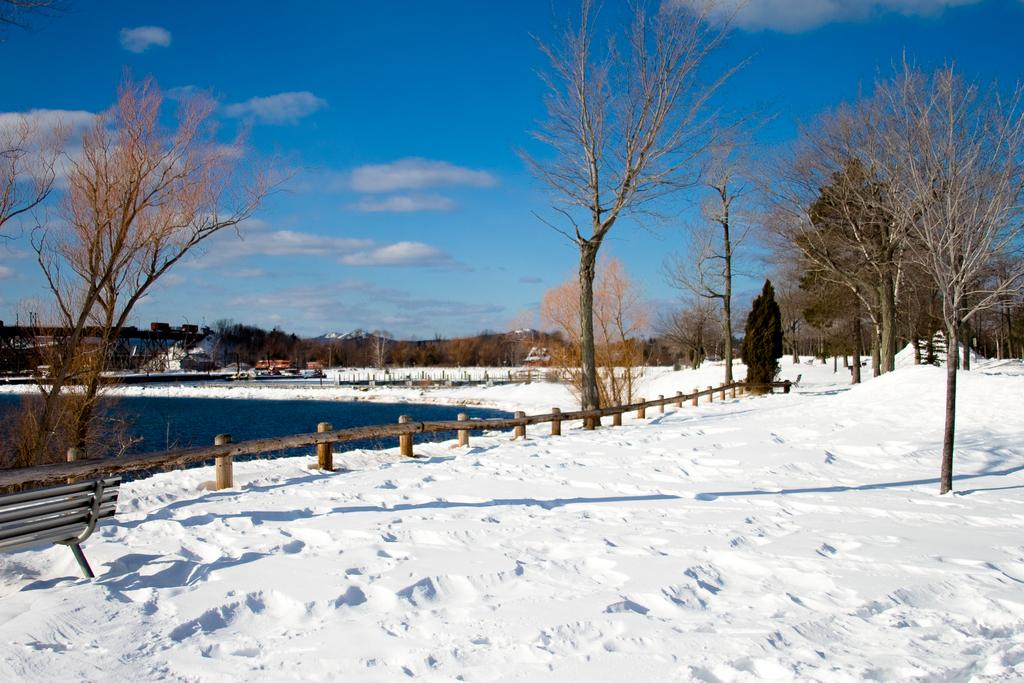What type of vegetation can be seen in the image? There are trees in the image. What is covering the ground in the image? The ground is covered with snow. What type of seating is present in the image? There is a bench on the ground. What is the condition of the sky in the image? The sky is clear in the image. Can you tell me how long the cable is in the image? There is no cable present in the image. What type of activity is taking place on the bench in the image? There is no activity taking place on the bench in the image; it is empty. 